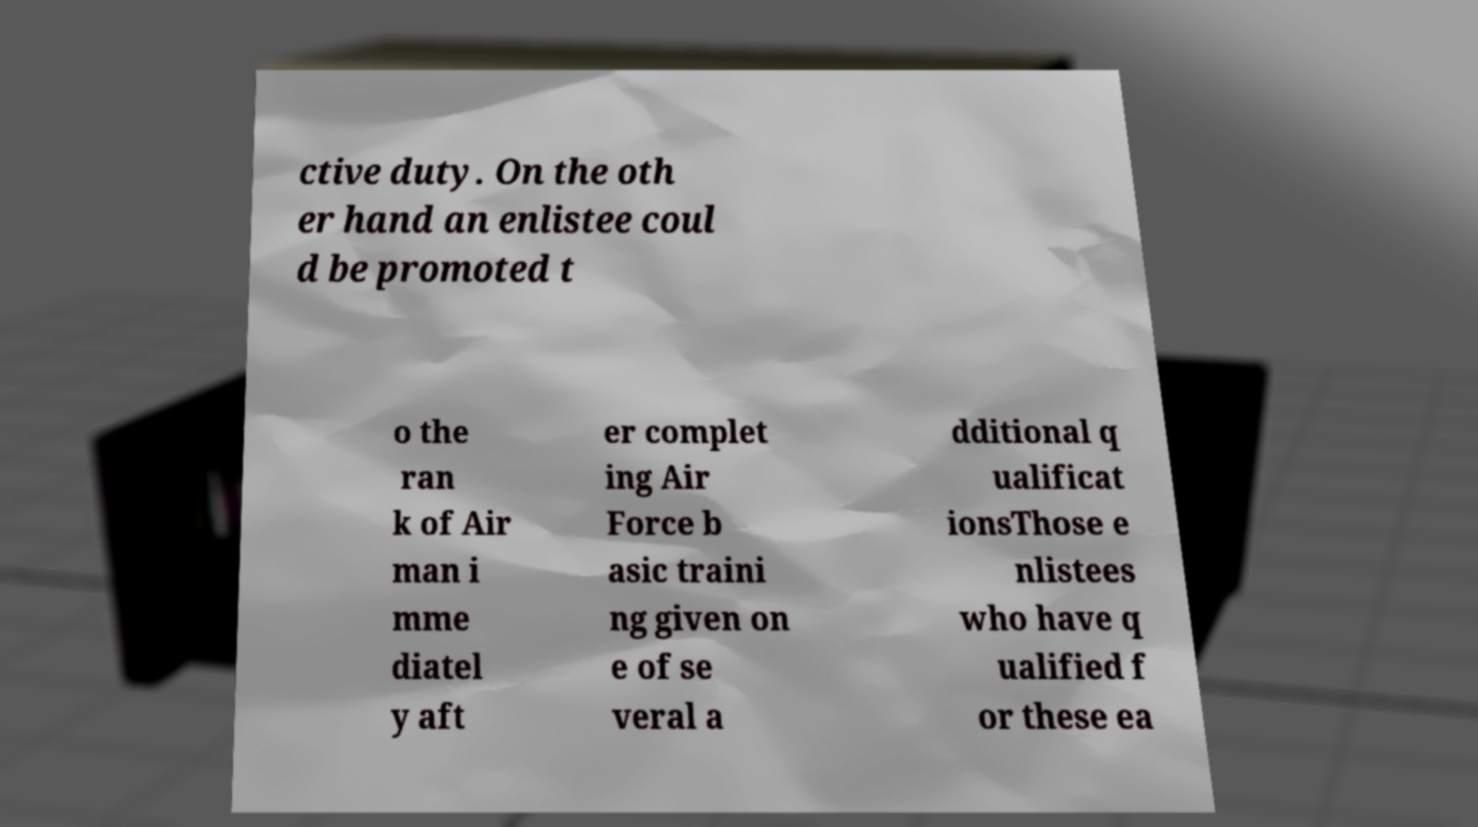Can you accurately transcribe the text from the provided image for me? ctive duty. On the oth er hand an enlistee coul d be promoted t o the ran k of Air man i mme diatel y aft er complet ing Air Force b asic traini ng given on e of se veral a dditional q ualificat ionsThose e nlistees who have q ualified f or these ea 